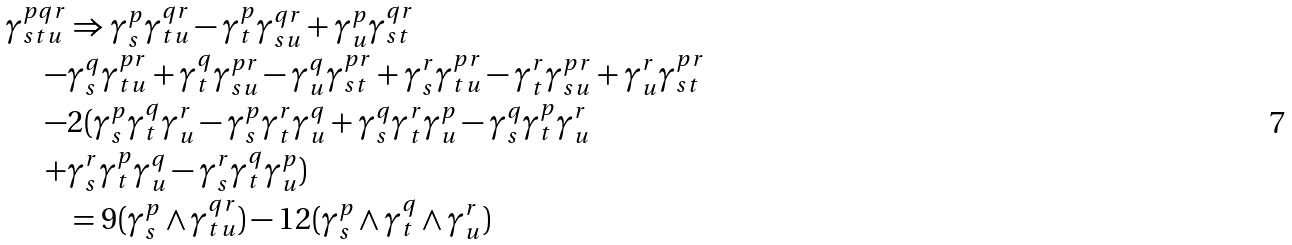<formula> <loc_0><loc_0><loc_500><loc_500>\gamma ^ { p q r } _ { s t u } & \Rightarrow \gamma ^ { p } _ { s } \gamma ^ { q r } _ { t u } - \gamma ^ { p } _ { t } \gamma ^ { q r } _ { s u } + \gamma ^ { p } _ { u } \gamma ^ { q r } _ { s t } \\ - & \gamma ^ { q } _ { s } \gamma ^ { p r } _ { t u } + \gamma ^ { q } _ { t } \gamma ^ { p r } _ { s u } - \gamma ^ { q } _ { u } \gamma ^ { p r } _ { s t } + \gamma ^ { r } _ { s } \gamma ^ { p r } _ { t u } - \gamma ^ { r } _ { t } \gamma ^ { p r } _ { s u } + \gamma ^ { r } _ { u } \gamma ^ { p r } _ { s t } \\ - & 2 ( \gamma ^ { p } _ { s } \gamma ^ { q } _ { t } \gamma ^ { r } _ { u } - \gamma ^ { p } _ { s } \gamma ^ { r } _ { t } \gamma ^ { q } _ { u } + \gamma ^ { q } _ { s } \gamma ^ { r } _ { t } \gamma ^ { p } _ { u } - \gamma ^ { q } _ { s } \gamma ^ { p } _ { t } \gamma ^ { r } _ { u } \\ + & \gamma ^ { r } _ { s } \gamma ^ { p } _ { t } \gamma ^ { q } _ { u } - \gamma ^ { r } _ { s } \gamma ^ { q } _ { t } \gamma ^ { p } _ { u } ) \\ & = 9 ( \gamma ^ { p } _ { s } \wedge \gamma ^ { q r } _ { t u } ) - 1 2 ( \gamma ^ { p } _ { s } \wedge \gamma ^ { q } _ { t } \wedge \gamma ^ { r } _ { u } )</formula> 